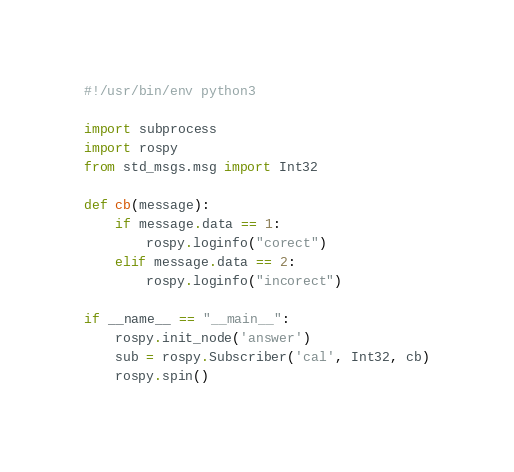<code> <loc_0><loc_0><loc_500><loc_500><_Python_>#!/usr/bin/env python3

import subprocess
import rospy
from std_msgs.msg import Int32

def cb(message):
    if message.data == 1:
        rospy.loginfo("corect")
    elif message.data == 2:
        rospy.loginfo("incorect")

if __name__ == "__main__":
    rospy.init_node('answer')
    sub = rospy.Subscriber('cal', Int32, cb)
    rospy.spin()
</code> 